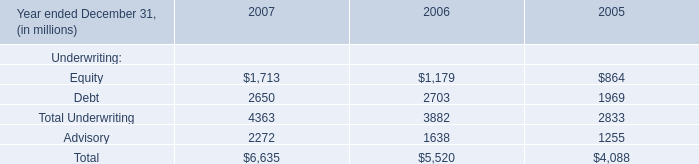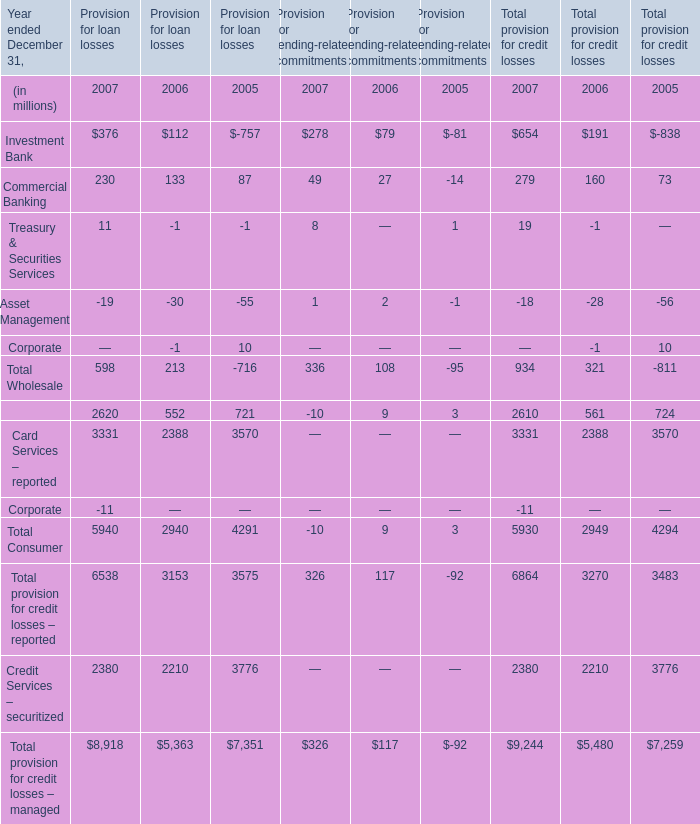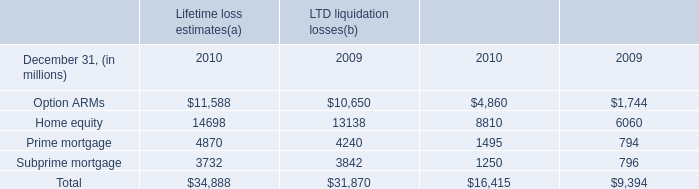What is the sum of Retail Financial Services of Provision for loan losses 2007, and Subprime mortgage of LTD liquidation losses 2009 ? 
Computations: (2620.0 + 3842.0)
Answer: 6462.0. 